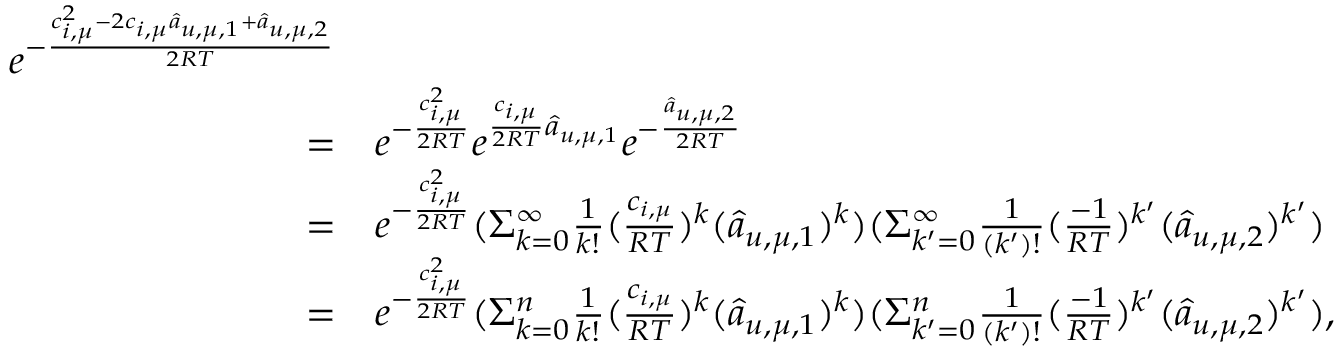Convert formula to latex. <formula><loc_0><loc_0><loc_500><loc_500>\begin{array} { r l } { e ^ { - \frac { c _ { i , \mu } ^ { 2 } - 2 c _ { i , \mu } \hat { a } _ { u , \mu , 1 } + \hat { a } _ { u , \mu , 2 } } { 2 R T } } } \\ { = } & { e ^ { - \frac { c _ { i , \mu } ^ { 2 } } { 2 R T } } e ^ { \frac { c _ { i , \mu } } { 2 R T } \hat { a } _ { u , \mu , 1 } } e ^ { - \frac { \hat { a } _ { u , \mu , 2 } } { 2 R T } } } \\ { = } & { e ^ { - \frac { c _ { i , \mu } ^ { 2 } } { 2 R T } } ( \Sigma _ { k = 0 } ^ { \infty } \frac { 1 } { k ! } ( \frac { c _ { i , \mu } } { R T } ) ^ { k } ( \hat { a } _ { u , \mu , 1 } ) ^ { k } ) ( \Sigma _ { k ^ { \prime } = 0 } ^ { \infty } \frac { 1 } { ( k ^ { \prime } ) ! } ( \frac { - 1 } { R T } ) ^ { k ^ { \prime } } ( \hat { a } _ { u , \mu , 2 } ) ^ { k ^ { \prime } } ) } \\ { = } & { e ^ { - \frac { c _ { i , \mu } ^ { 2 } } { 2 R T } } ( \Sigma _ { k = 0 } ^ { n } \frac { 1 } { k ! } ( \frac { c _ { i , \mu } } { R T } ) ^ { k } ( \hat { a } _ { u , \mu , 1 } ) ^ { k } ) ( \Sigma _ { k ^ { \prime } = 0 } ^ { n } \frac { 1 } { ( k ^ { \prime } ) ! } ( \frac { - 1 } { R T } ) ^ { k ^ { \prime } } ( \hat { a } _ { u , \mu , 2 } ) ^ { k ^ { \prime } } ) , } \end{array}</formula> 